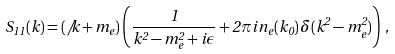<formula> <loc_0><loc_0><loc_500><loc_500>S _ { 1 1 } ( k ) = ( \not { \, k } + m _ { e } ) \left ( \frac { 1 } { k ^ { 2 } - m _ { e } ^ { 2 } + i \epsilon } + 2 \pi i \, n _ { e } ( k _ { 0 } ) \, \delta ( k ^ { 2 } - m _ { e } ^ { 2 } ) \right ) \, ,</formula> 